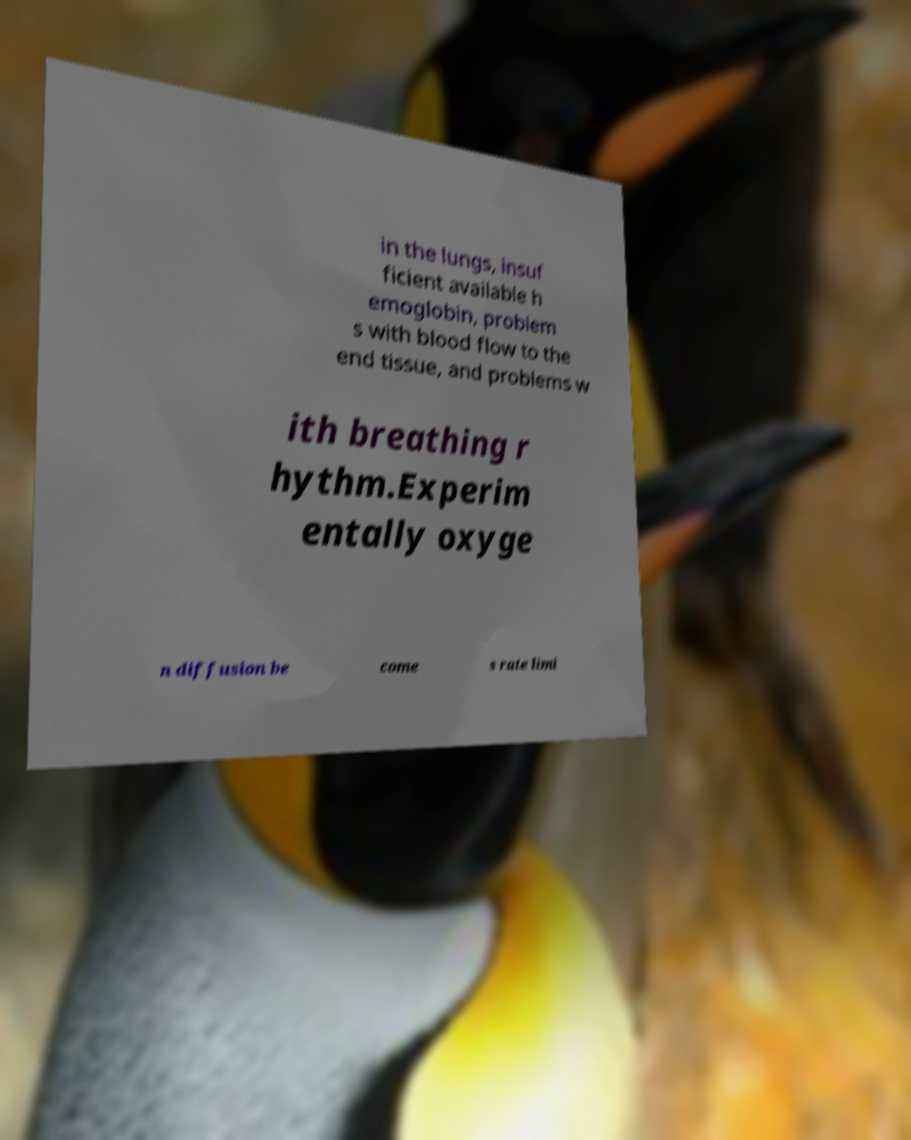Please read and relay the text visible in this image. What does it say? in the lungs, insuf ficient available h emoglobin, problem s with blood flow to the end tissue, and problems w ith breathing r hythm.Experim entally oxyge n diffusion be come s rate limi 